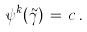<formula> <loc_0><loc_0><loc_500><loc_500>\psi ^ { k } ( \tilde { \gamma } ) \, = \, c \, .</formula> 